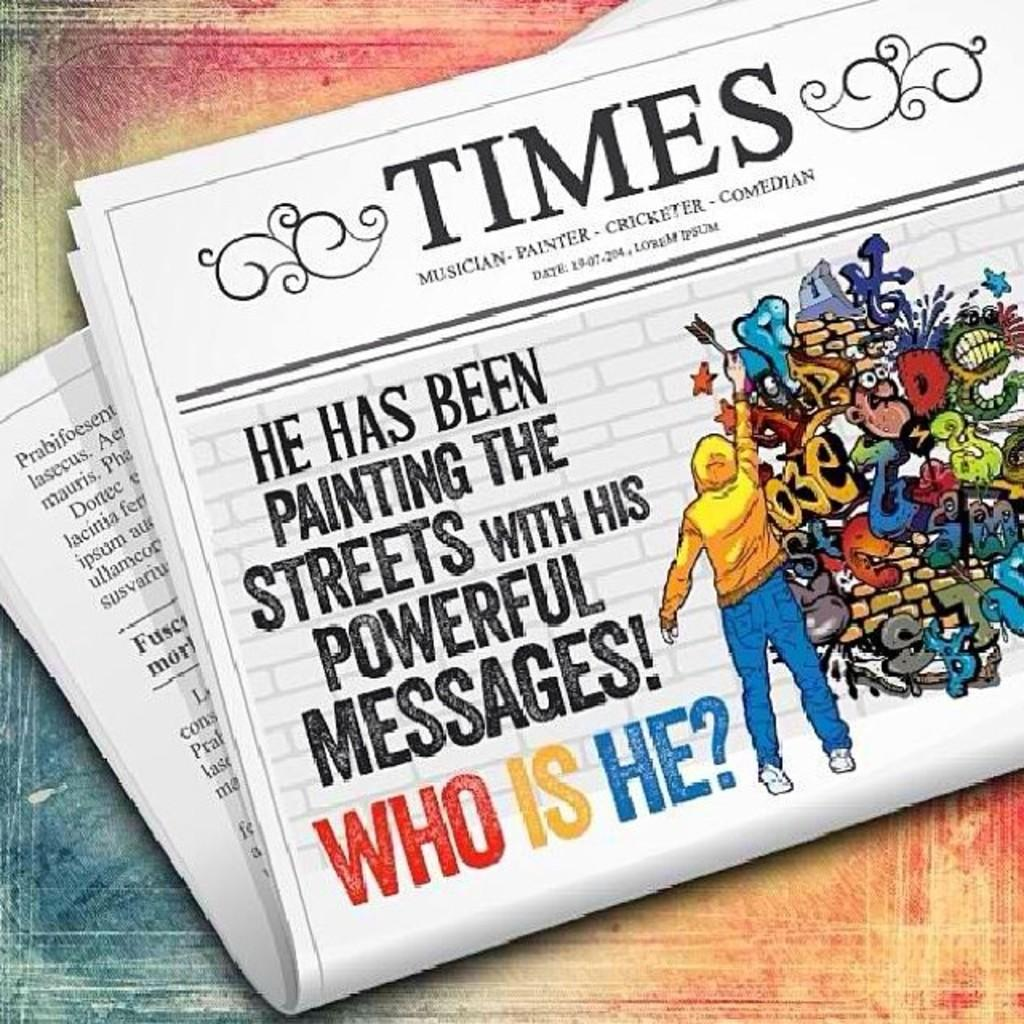<image>
Render a clear and concise summary of the photo. Times newspaper front cover story he has been painting the streets with his powerful messages! 